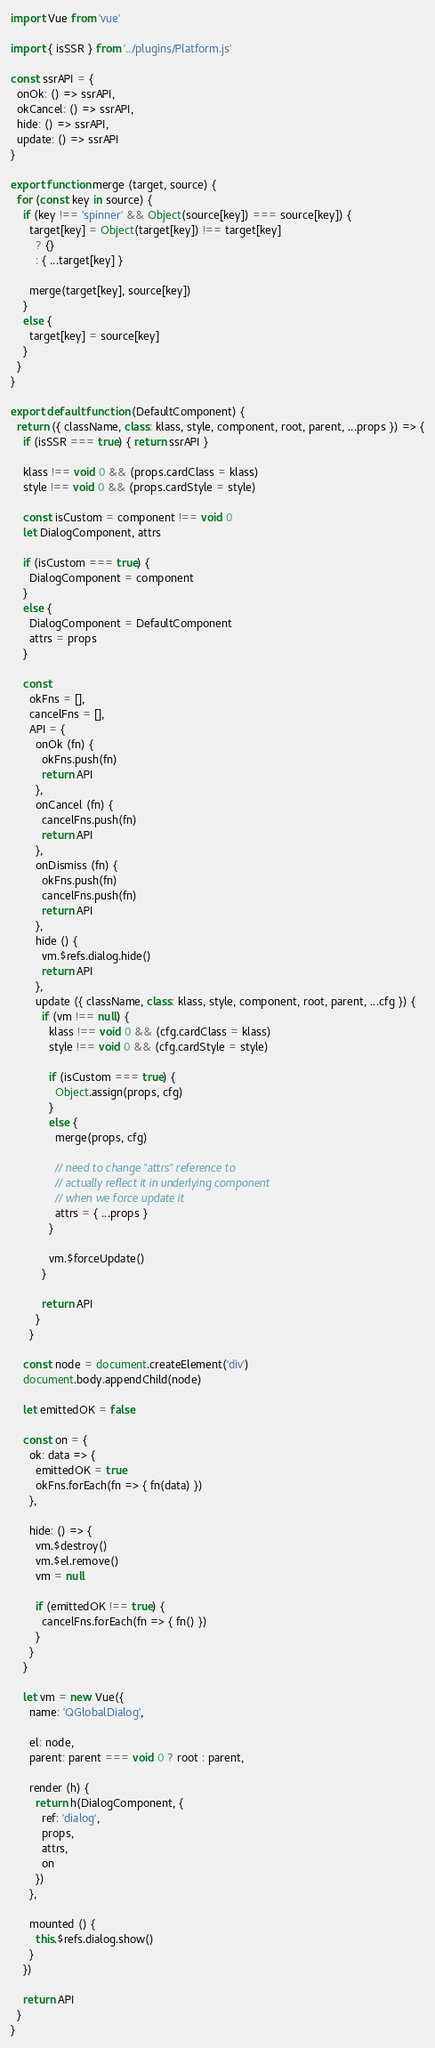<code> <loc_0><loc_0><loc_500><loc_500><_JavaScript_>import Vue from 'vue'

import { isSSR } from '../plugins/Platform.js'

const ssrAPI = {
  onOk: () => ssrAPI,
  okCancel: () => ssrAPI,
  hide: () => ssrAPI,
  update: () => ssrAPI
}

export function merge (target, source) {
  for (const key in source) {
    if (key !== 'spinner' && Object(source[key]) === source[key]) {
      target[key] = Object(target[key]) !== target[key]
        ? {}
        : { ...target[key] }

      merge(target[key], source[key])
    }
    else {
      target[key] = source[key]
    }
  }
}

export default function (DefaultComponent) {
  return ({ className, class: klass, style, component, root, parent, ...props }) => {
    if (isSSR === true) { return ssrAPI }

    klass !== void 0 && (props.cardClass = klass)
    style !== void 0 && (props.cardStyle = style)

    const isCustom = component !== void 0
    let DialogComponent, attrs

    if (isCustom === true) {
      DialogComponent = component
    }
    else {
      DialogComponent = DefaultComponent
      attrs = props
    }

    const
      okFns = [],
      cancelFns = [],
      API = {
        onOk (fn) {
          okFns.push(fn)
          return API
        },
        onCancel (fn) {
          cancelFns.push(fn)
          return API
        },
        onDismiss (fn) {
          okFns.push(fn)
          cancelFns.push(fn)
          return API
        },
        hide () {
          vm.$refs.dialog.hide()
          return API
        },
        update ({ className, class: klass, style, component, root, parent, ...cfg }) {
          if (vm !== null) {
            klass !== void 0 && (cfg.cardClass = klass)
            style !== void 0 && (cfg.cardStyle = style)

            if (isCustom === true) {
              Object.assign(props, cfg)
            }
            else {
              merge(props, cfg)

              // need to change "attrs" reference to
              // actually reflect it in underlying component
              // when we force update it
              attrs = { ...props }
            }

            vm.$forceUpdate()
          }

          return API
        }
      }

    const node = document.createElement('div')
    document.body.appendChild(node)

    let emittedOK = false

    const on = {
      ok: data => {
        emittedOK = true
        okFns.forEach(fn => { fn(data) })
      },

      hide: () => {
        vm.$destroy()
        vm.$el.remove()
        vm = null

        if (emittedOK !== true) {
          cancelFns.forEach(fn => { fn() })
        }
      }
    }

    let vm = new Vue({
      name: 'QGlobalDialog',

      el: node,
      parent: parent === void 0 ? root : parent,

      render (h) {
        return h(DialogComponent, {
          ref: 'dialog',
          props,
          attrs,
          on
        })
      },

      mounted () {
        this.$refs.dialog.show()
      }
    })

    return API
  }
}
</code> 